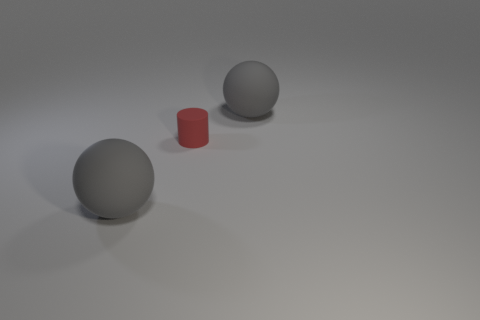Is the size of the gray rubber sphere to the left of the red object the same as the red thing?
Make the answer very short. No. What number of blocks are either rubber objects or small objects?
Your answer should be compact. 0. What is the ball in front of the small cylinder made of?
Provide a succinct answer. Rubber. Are there fewer small red cylinders than large purple metallic cubes?
Ensure brevity in your answer.  No. What is the size of the gray thing that is behind the rubber ball in front of the large gray matte thing behind the tiny red matte cylinder?
Keep it short and to the point. Large. What number of other objects are there of the same color as the rubber cylinder?
Offer a very short reply. 0. Does the sphere in front of the red object have the same color as the small matte thing?
Your answer should be very brief. No. What number of things are either small rubber cylinders or large gray objects?
Give a very brief answer. 3. There is a big object to the left of the small rubber object; what color is it?
Your answer should be compact. Gray. Are there fewer rubber cylinders behind the small red matte object than small cylinders?
Ensure brevity in your answer.  Yes. 